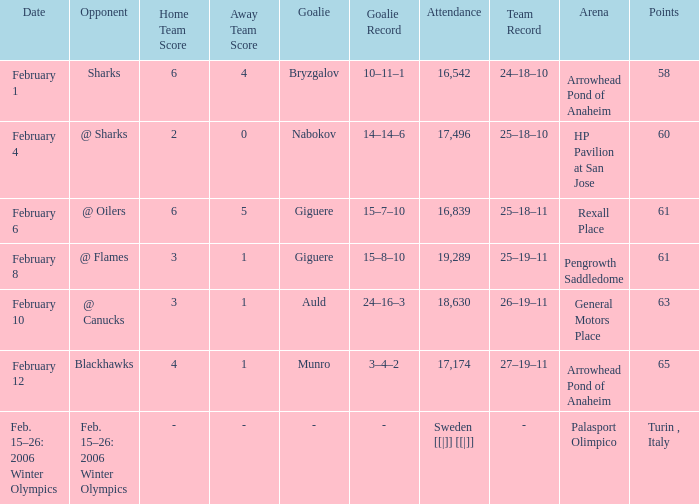What is the record at Palasport Olimpico? Sweden [[|]] [[|]]. 